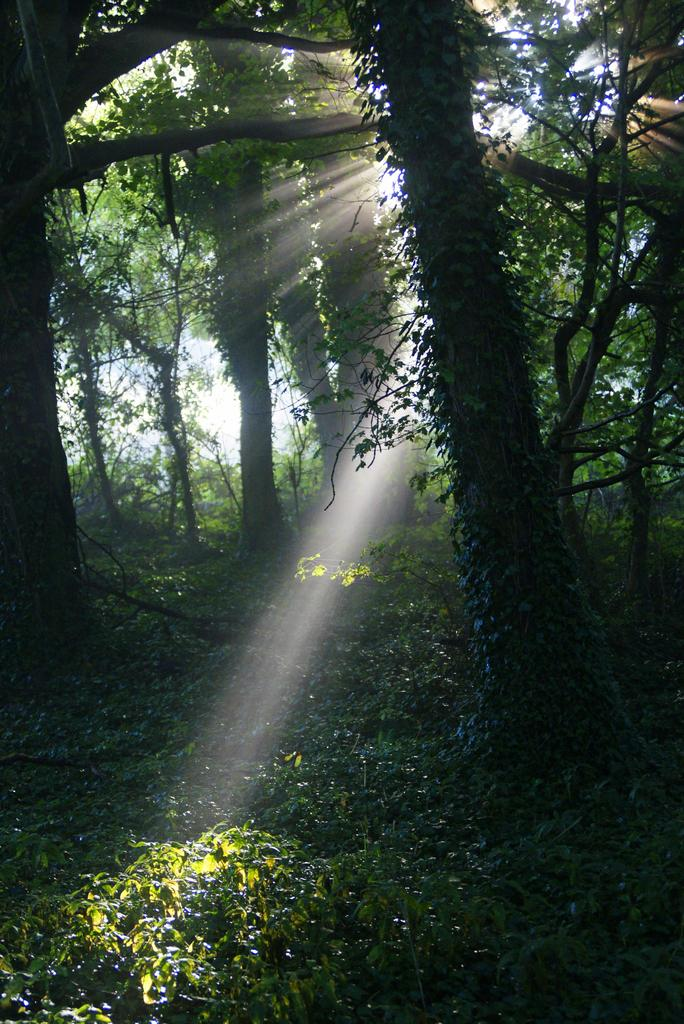What type of vegetation is present at the bottom of the image? There are trees at the bottom of the image. Where else can trees be seen in the image? Trees can also be seen on the right side of the image. What is visible in the background of the image? The sun, sky, and trees are visible in the background of the image. How are the sun rays affecting the trees in the image? Sun rays are falling on the trees in the image. What type of hall can be seen in the image? There is no hall present in the image; it features trees and a sky with sun rays. 